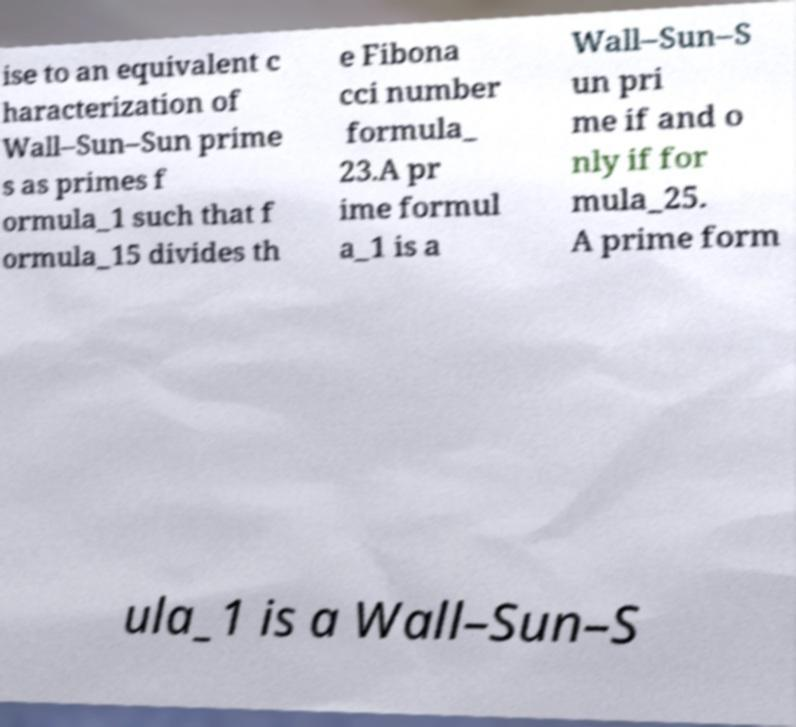Can you read and provide the text displayed in the image?This photo seems to have some interesting text. Can you extract and type it out for me? ise to an equivalent c haracterization of Wall–Sun–Sun prime s as primes f ormula_1 such that f ormula_15 divides th e Fibona cci number formula_ 23.A pr ime formul a_1 is a Wall–Sun–S un pri me if and o nly if for mula_25. A prime form ula_1 is a Wall–Sun–S 